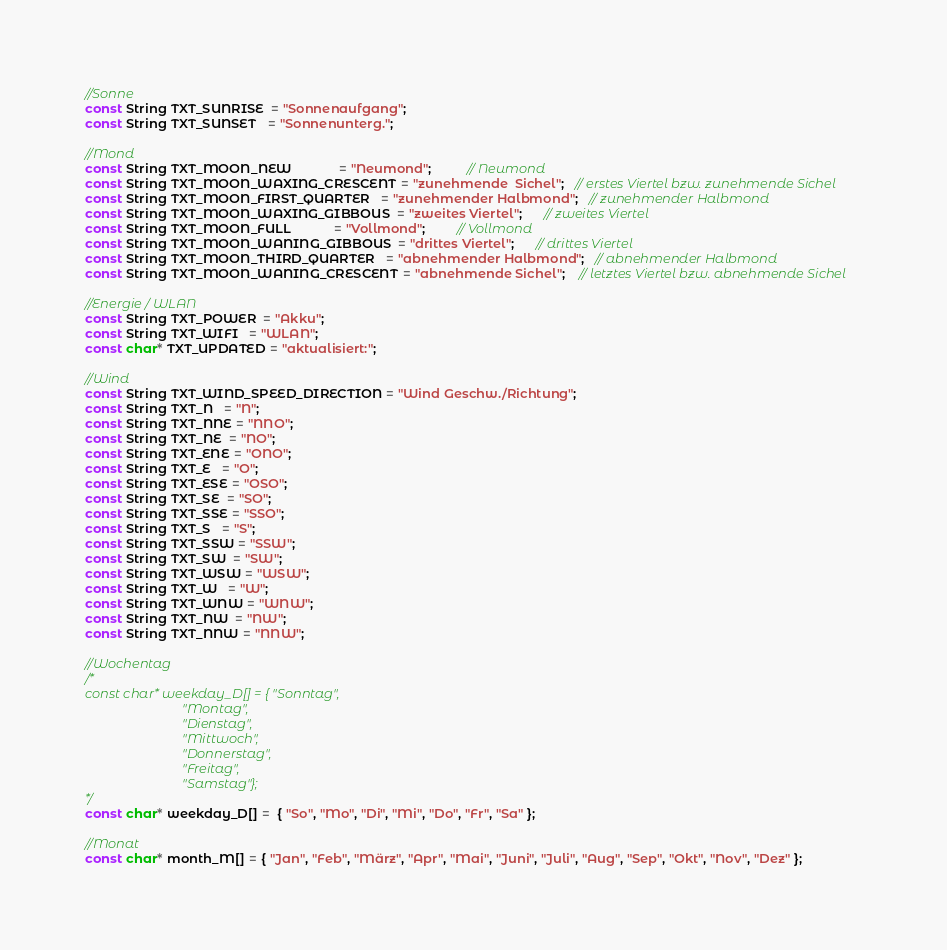<code> <loc_0><loc_0><loc_500><loc_500><_C_>
//Sonne
const String TXT_SUNRISE  = "Sonnenaufgang";
const String TXT_SUNSET   = "Sonnenunterg.";

//Mond
const String TXT_MOON_NEW             = "Neumond";          // Neumond
const String TXT_MOON_WAXING_CRESCENT = "zunehmende  Sichel";   // erstes Viertel bzw. zunehmende Sichel
const String TXT_MOON_FIRST_QUARTER   = "zunehmender Halbmond";   // zunehmender Halbmond 
const String TXT_MOON_WAXING_GIBBOUS  = "zweites Viertel";      // zweites Viertel
const String TXT_MOON_FULL            = "Vollmond";         // Vollmond
const String TXT_MOON_WANING_GIBBOUS  = "drittes Viertel";      // drittes Viertel 
const String TXT_MOON_THIRD_QUARTER   = "abnehmender Halbmond";   // abnehmender Halbmond
const String TXT_MOON_WANING_CRESCENT = "abnehmende Sichel";    // letztes Viertel bzw. abnehmende Sichel 

//Energie / WLAN
const String TXT_POWER  = "Akku";
const String TXT_WIFI   = "WLAN";
const char* TXT_UPDATED = "aktualisiert:";

//Wind
const String TXT_WIND_SPEED_DIRECTION = "Wind Geschw./Richtung";
const String TXT_N   = "N";
const String TXT_NNE = "NNO";
const String TXT_NE  = "NO";
const String TXT_ENE = "ONO";
const String TXT_E   = "O";
const String TXT_ESE = "OSO";
const String TXT_SE  = "SO";
const String TXT_SSE = "SSO";
const String TXT_S   = "S";
const String TXT_SSW = "SSW";
const String TXT_SW  = "SW";
const String TXT_WSW = "WSW";
const String TXT_W   = "W";
const String TXT_WNW = "WNW";
const String TXT_NW  = "NW";
const String TXT_NNW = "NNW";

//Wochentag
/*
const char* weekday_D[] = { "Sonntag",
                             "Montag",   
                             "Dienstag", 
                             "Mittwoch", 
                             "Donnerstag", 
                             "Freitag", 
                             "Samstag"};
*/
const char* weekday_D[] =  { "So", "Mo", "Di", "Mi", "Do", "Fr", "Sa" };

//Monat
const char* month_M[] = { "Jan", "Feb", "März", "Apr", "Mai", "Juni", "Juli", "Aug", "Sep", "Okt", "Nov", "Dez" };
</code> 